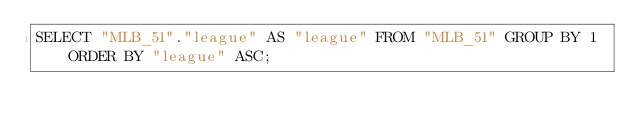Convert code to text. <code><loc_0><loc_0><loc_500><loc_500><_SQL_>SELECT "MLB_51"."league" AS "league" FROM "MLB_51" GROUP BY 1 ORDER BY "league" ASC;
</code> 